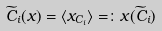<formula> <loc_0><loc_0><loc_500><loc_500>\widetilde { C } _ { i } ( x ) = \langle x _ { C _ { i } } \rangle = \colon x ( \widetilde { C } _ { i } )</formula> 